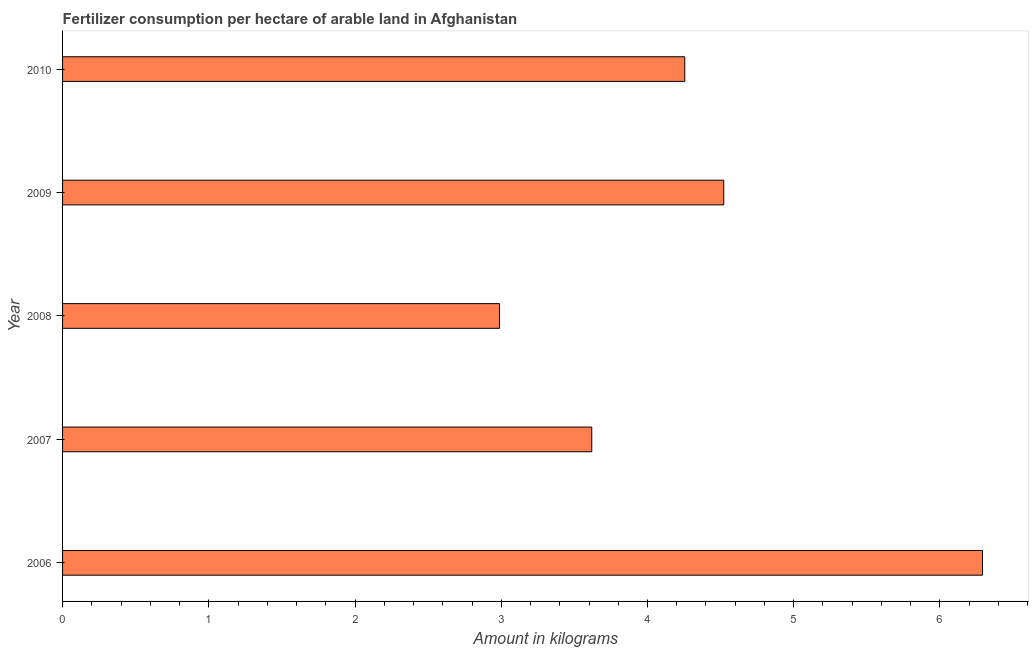What is the title of the graph?
Offer a terse response. Fertilizer consumption per hectare of arable land in Afghanistan . What is the label or title of the X-axis?
Provide a succinct answer. Amount in kilograms. What is the label or title of the Y-axis?
Ensure brevity in your answer.  Year. What is the amount of fertilizer consumption in 2009?
Keep it short and to the point. 4.52. Across all years, what is the maximum amount of fertilizer consumption?
Your answer should be compact. 6.29. Across all years, what is the minimum amount of fertilizer consumption?
Make the answer very short. 2.99. In which year was the amount of fertilizer consumption minimum?
Offer a very short reply. 2008. What is the sum of the amount of fertilizer consumption?
Make the answer very short. 21.67. What is the difference between the amount of fertilizer consumption in 2006 and 2009?
Your answer should be compact. 1.77. What is the average amount of fertilizer consumption per year?
Your answer should be very brief. 4.33. What is the median amount of fertilizer consumption?
Provide a succinct answer. 4.25. In how many years, is the amount of fertilizer consumption greater than 2.6 kg?
Keep it short and to the point. 5. What is the ratio of the amount of fertilizer consumption in 2009 to that in 2010?
Offer a terse response. 1.06. Is the difference between the amount of fertilizer consumption in 2006 and 2007 greater than the difference between any two years?
Ensure brevity in your answer.  No. What is the difference between the highest and the second highest amount of fertilizer consumption?
Ensure brevity in your answer.  1.77. Is the sum of the amount of fertilizer consumption in 2008 and 2010 greater than the maximum amount of fertilizer consumption across all years?
Ensure brevity in your answer.  Yes. What is the difference between the highest and the lowest amount of fertilizer consumption?
Offer a very short reply. 3.3. How many bars are there?
Give a very brief answer. 5. How many years are there in the graph?
Your response must be concise. 5. What is the difference between two consecutive major ticks on the X-axis?
Provide a short and direct response. 1. What is the Amount in kilograms in 2006?
Your answer should be compact. 6.29. What is the Amount in kilograms in 2007?
Provide a short and direct response. 3.62. What is the Amount in kilograms in 2008?
Provide a succinct answer. 2.99. What is the Amount in kilograms in 2009?
Make the answer very short. 4.52. What is the Amount in kilograms in 2010?
Provide a succinct answer. 4.25. What is the difference between the Amount in kilograms in 2006 and 2007?
Provide a succinct answer. 2.67. What is the difference between the Amount in kilograms in 2006 and 2008?
Make the answer very short. 3.3. What is the difference between the Amount in kilograms in 2006 and 2009?
Your answer should be compact. 1.77. What is the difference between the Amount in kilograms in 2006 and 2010?
Your answer should be compact. 2.04. What is the difference between the Amount in kilograms in 2007 and 2008?
Keep it short and to the point. 0.63. What is the difference between the Amount in kilograms in 2007 and 2009?
Provide a short and direct response. -0.9. What is the difference between the Amount in kilograms in 2007 and 2010?
Give a very brief answer. -0.64. What is the difference between the Amount in kilograms in 2008 and 2009?
Provide a succinct answer. -1.53. What is the difference between the Amount in kilograms in 2008 and 2010?
Offer a very short reply. -1.27. What is the difference between the Amount in kilograms in 2009 and 2010?
Your response must be concise. 0.27. What is the ratio of the Amount in kilograms in 2006 to that in 2007?
Your answer should be compact. 1.74. What is the ratio of the Amount in kilograms in 2006 to that in 2008?
Keep it short and to the point. 2.1. What is the ratio of the Amount in kilograms in 2006 to that in 2009?
Provide a succinct answer. 1.39. What is the ratio of the Amount in kilograms in 2006 to that in 2010?
Offer a very short reply. 1.48. What is the ratio of the Amount in kilograms in 2007 to that in 2008?
Provide a short and direct response. 1.21. What is the ratio of the Amount in kilograms in 2007 to that in 2010?
Provide a short and direct response. 0.85. What is the ratio of the Amount in kilograms in 2008 to that in 2009?
Make the answer very short. 0.66. What is the ratio of the Amount in kilograms in 2008 to that in 2010?
Offer a very short reply. 0.7. What is the ratio of the Amount in kilograms in 2009 to that in 2010?
Your response must be concise. 1.06. 